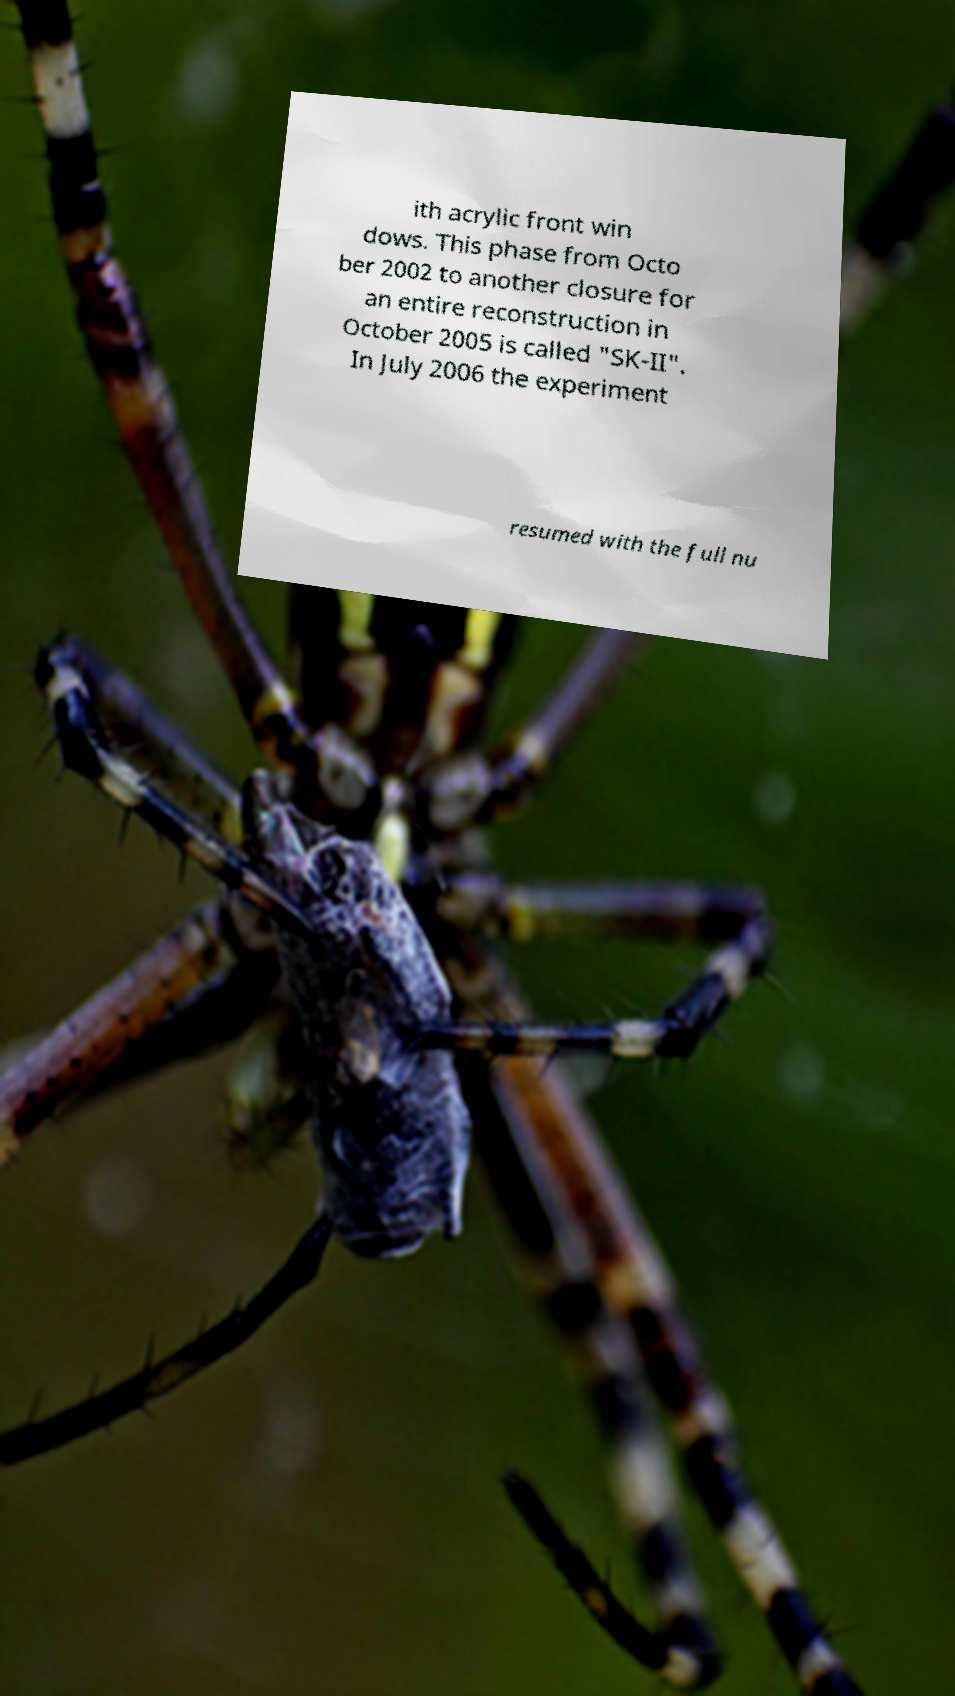Could you assist in decoding the text presented in this image and type it out clearly? ith acrylic front win dows. This phase from Octo ber 2002 to another closure for an entire reconstruction in October 2005 is called "SK-II". In July 2006 the experiment resumed with the full nu 